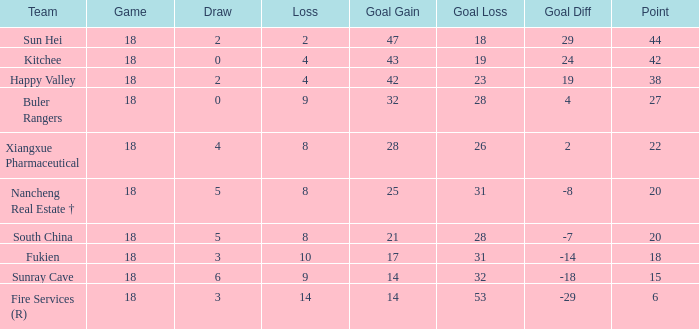What team with a Game smaller than 18 has the lowest Goal Gain? None. 